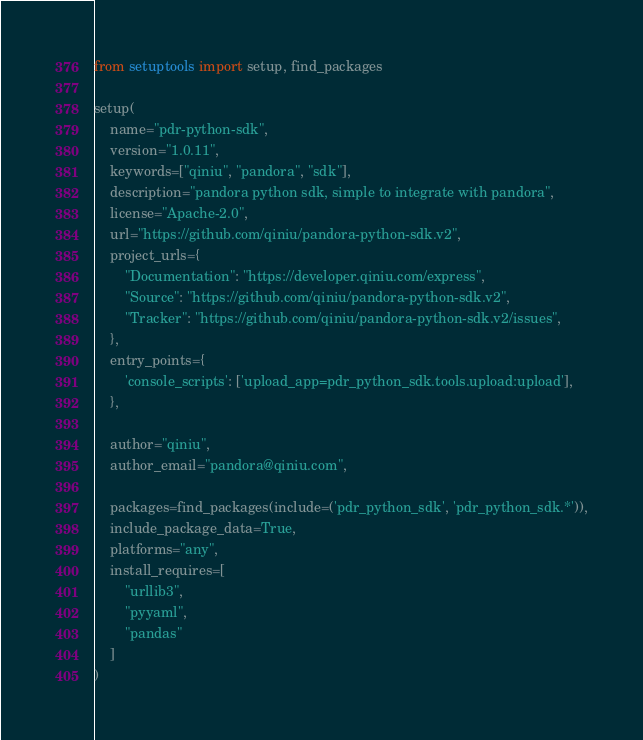<code> <loc_0><loc_0><loc_500><loc_500><_Python_>from setuptools import setup, find_packages

setup(
    name="pdr-python-sdk",
    version="1.0.11",
    keywords=["qiniu", "pandora", "sdk"],
    description="pandora python sdk, simple to integrate with pandora",
    license="Apache-2.0",
    url="https://github.com/qiniu/pandora-python-sdk.v2",
    project_urls={
        "Documentation": "https://developer.qiniu.com/express",
        "Source": "https://github.com/qiniu/pandora-python-sdk.v2",
        "Tracker": "https://github.com/qiniu/pandora-python-sdk.v2/issues",
    },
    entry_points={
        'console_scripts': ['upload_app=pdr_python_sdk.tools.upload:upload'],
    },

    author="qiniu",
    author_email="pandora@qiniu.com",

    packages=find_packages(include=('pdr_python_sdk', 'pdr_python_sdk.*')),
    include_package_data=True,
    platforms="any",
    install_requires=[
        "urllib3",
        "pyyaml",
        "pandas"
    ]
)
</code> 